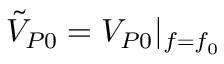Convert formula to latex. <formula><loc_0><loc_0><loc_500><loc_500>\tilde { V } _ { P 0 } = V _ { P 0 } | _ { f = f _ { 0 } }</formula> 